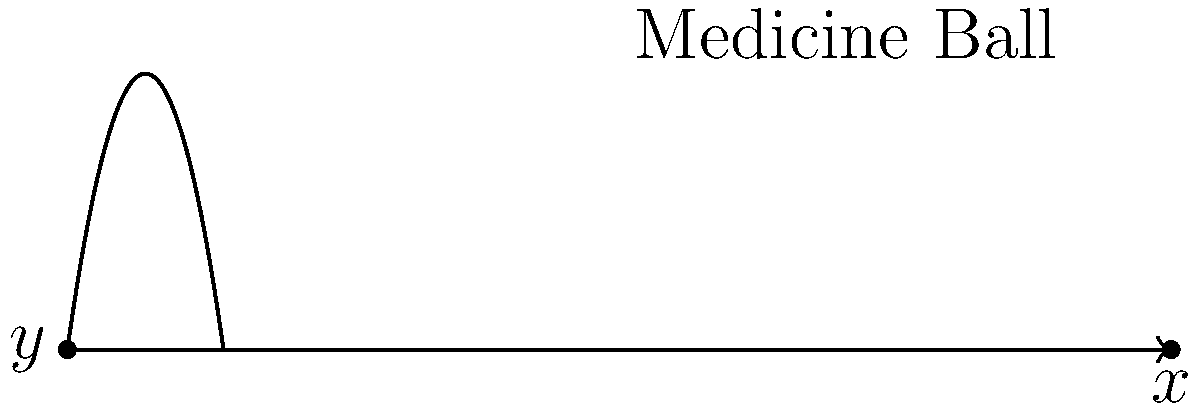During a high-intensity workout, you throw a 5 kg medicine ball with an initial velocity of 10 m/s at a 45-degree angle. Assuming air resistance is negligible, what is the maximum height reached by the medicine ball? To find the maximum height reached by the medicine ball, we'll follow these steps:

1) The vertical component of the initial velocity is given by:
   $v_{0y} = v_0 \sin(\theta) = 10 \cdot \sin(45°) = 10 \cdot \frac{\sqrt{2}}{2} \approx 7.07$ m/s

2) The time to reach the maximum height is when the vertical velocity becomes zero:
   $v_y = v_{0y} - gt = 0$
   $t = \frac{v_{0y}}{g} = \frac{7.07}{9.8} \approx 0.72$ s

3) The maximum height can be calculated using the equation:
   $y = v_{0y}t - \frac{1}{2}gt^2$

4) Substituting the values:
   $y_{max} = 7.07 \cdot 0.72 - \frac{1}{2} \cdot 9.8 \cdot 0.72^2$
   $y_{max} = 5.09 - 2.54 = 2.55$ m

Therefore, the maximum height reached by the medicine ball is approximately 2.55 meters.
Answer: 2.55 m 